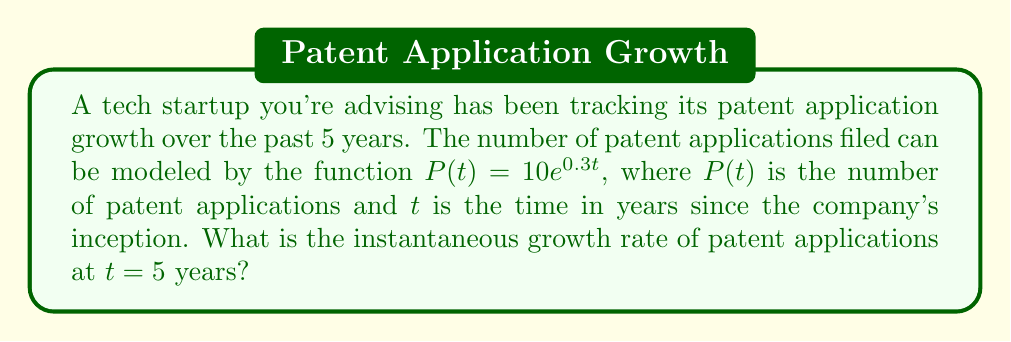Can you solve this math problem? To find the instantaneous growth rate at $t = 5$ years, we need to follow these steps:

1) The given function is $P(t) = 10e^{0.3t}$

2) The instantaneous growth rate is given by the derivative of $P(t)$ with respect to $t$:

   $$\frac{dP}{dt} = 10 \cdot 0.3e^{0.3t} = 3e^{0.3t}$$

3) To find the growth rate at $t = 5$, we substitute $t = 5$ into this derivative:

   $$\frac{dP}{dt}\bigg|_{t=5} = 3e^{0.3(5)} = 3e^{1.5}$$

4) Calculate $e^{1.5}$:
   
   $$e^{1.5} \approx 4.4817$$

5) Multiply by 3:

   $$3e^{1.5} \approx 3 \cdot 4.4817 = 13.4451$$

Therefore, the instantaneous growth rate at $t = 5$ years is approximately 13.4451 patent applications per year.
Answer: 13.4451 patent applications/year 